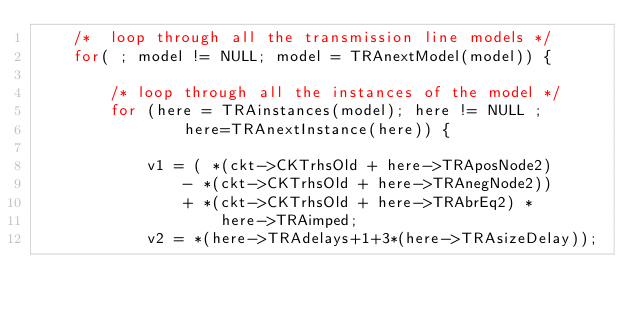<code> <loc_0><loc_0><loc_500><loc_500><_C_>    /*  loop through all the transmission line models */
    for( ; model != NULL; model = TRAnextModel(model)) {

        /* loop through all the instances of the model */
        for (here = TRAinstances(model); here != NULL ;
                here=TRAnextInstance(here)) {

            v1 = ( *(ckt->CKTrhsOld + here->TRAposNode2)
                - *(ckt->CKTrhsOld + here->TRAnegNode2))
                + *(ckt->CKTrhsOld + here->TRAbrEq2) *
                    here->TRAimped;
            v2 = *(here->TRAdelays+1+3*(here->TRAsizeDelay));</code> 